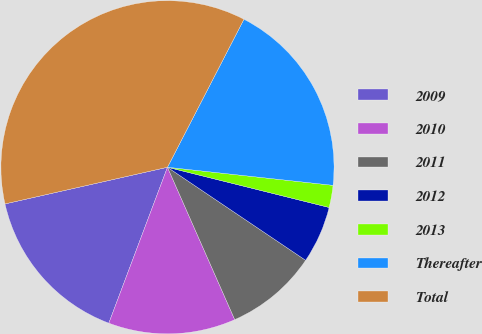<chart> <loc_0><loc_0><loc_500><loc_500><pie_chart><fcel>2009<fcel>2010<fcel>2011<fcel>2012<fcel>2013<fcel>Thereafter<fcel>Total<nl><fcel>15.74%<fcel>12.34%<fcel>8.95%<fcel>5.55%<fcel>2.15%<fcel>19.14%<fcel>36.12%<nl></chart> 